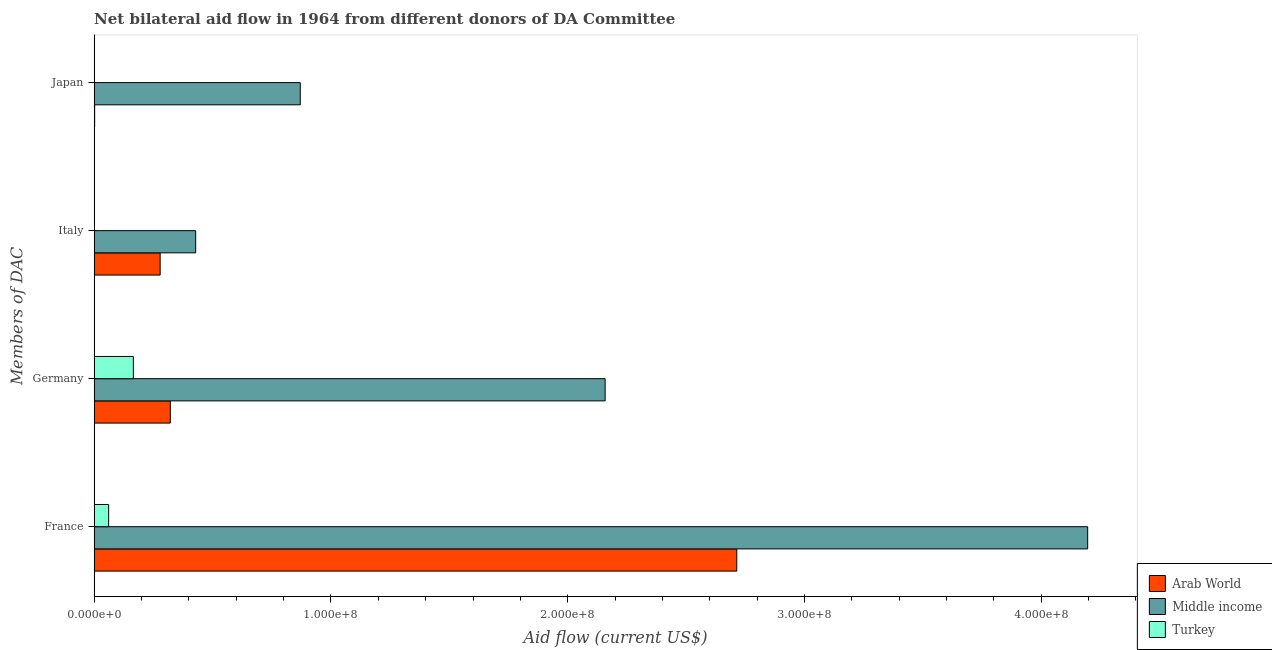How many different coloured bars are there?
Your answer should be very brief. 3. How many bars are there on the 1st tick from the bottom?
Offer a terse response. 3. What is the label of the 2nd group of bars from the top?
Your answer should be very brief. Italy. What is the amount of aid given by germany in Middle income?
Provide a short and direct response. 2.16e+08. Across all countries, what is the maximum amount of aid given by france?
Keep it short and to the point. 4.20e+08. Across all countries, what is the minimum amount of aid given by germany?
Provide a short and direct response. 1.65e+07. What is the total amount of aid given by italy in the graph?
Your answer should be very brief. 7.07e+07. What is the difference between the amount of aid given by germany in Turkey and that in Middle income?
Your answer should be compact. -1.99e+08. What is the difference between the amount of aid given by germany in Middle income and the amount of aid given by italy in Turkey?
Your answer should be very brief. 2.16e+08. What is the average amount of aid given by germany per country?
Give a very brief answer. 8.82e+07. What is the difference between the amount of aid given by japan and amount of aid given by france in Turkey?
Provide a succinct answer. -6.07e+06. In how many countries, is the amount of aid given by italy greater than 420000000 US$?
Offer a very short reply. 0. What is the ratio of the amount of aid given by germany in Arab World to that in Turkey?
Ensure brevity in your answer.  1.94. What is the difference between the highest and the second highest amount of aid given by germany?
Your answer should be compact. 1.84e+08. What is the difference between the highest and the lowest amount of aid given by italy?
Your answer should be compact. 4.29e+07. Is the sum of the amount of aid given by germany in Arab World and Middle income greater than the maximum amount of aid given by france across all countries?
Your response must be concise. No. How many bars are there?
Your answer should be compact. 11. Are the values on the major ticks of X-axis written in scientific E-notation?
Make the answer very short. Yes. Does the graph contain any zero values?
Your response must be concise. Yes. Does the graph contain grids?
Give a very brief answer. No. Where does the legend appear in the graph?
Your answer should be compact. Bottom right. How many legend labels are there?
Give a very brief answer. 3. How are the legend labels stacked?
Your answer should be very brief. Vertical. What is the title of the graph?
Your response must be concise. Net bilateral aid flow in 1964 from different donors of DA Committee. Does "Middle income" appear as one of the legend labels in the graph?
Keep it short and to the point. Yes. What is the label or title of the X-axis?
Offer a terse response. Aid flow (current US$). What is the label or title of the Y-axis?
Provide a succinct answer. Members of DAC. What is the Aid flow (current US$) in Arab World in France?
Offer a very short reply. 2.71e+08. What is the Aid flow (current US$) in Middle income in France?
Offer a terse response. 4.20e+08. What is the Aid flow (current US$) of Turkey in France?
Provide a succinct answer. 6.10e+06. What is the Aid flow (current US$) of Arab World in Germany?
Ensure brevity in your answer.  3.22e+07. What is the Aid flow (current US$) in Middle income in Germany?
Offer a terse response. 2.16e+08. What is the Aid flow (current US$) of Turkey in Germany?
Make the answer very short. 1.65e+07. What is the Aid flow (current US$) of Arab World in Italy?
Give a very brief answer. 2.79e+07. What is the Aid flow (current US$) in Middle income in Italy?
Your answer should be very brief. 4.29e+07. What is the Aid flow (current US$) in Turkey in Italy?
Your answer should be very brief. 0. What is the Aid flow (current US$) in Middle income in Japan?
Provide a short and direct response. 8.70e+07. What is the Aid flow (current US$) of Turkey in Japan?
Make the answer very short. 3.00e+04. Across all Members of DAC, what is the maximum Aid flow (current US$) in Arab World?
Keep it short and to the point. 2.71e+08. Across all Members of DAC, what is the maximum Aid flow (current US$) of Middle income?
Provide a succinct answer. 4.20e+08. Across all Members of DAC, what is the maximum Aid flow (current US$) in Turkey?
Offer a terse response. 1.65e+07. Across all Members of DAC, what is the minimum Aid flow (current US$) in Middle income?
Provide a succinct answer. 4.29e+07. Across all Members of DAC, what is the minimum Aid flow (current US$) in Turkey?
Provide a short and direct response. 0. What is the total Aid flow (current US$) in Arab World in the graph?
Your answer should be compact. 3.32e+08. What is the total Aid flow (current US$) of Middle income in the graph?
Ensure brevity in your answer.  7.65e+08. What is the total Aid flow (current US$) in Turkey in the graph?
Give a very brief answer. 2.27e+07. What is the difference between the Aid flow (current US$) in Arab World in France and that in Germany?
Make the answer very short. 2.39e+08. What is the difference between the Aid flow (current US$) in Middle income in France and that in Germany?
Your answer should be compact. 2.04e+08. What is the difference between the Aid flow (current US$) in Turkey in France and that in Germany?
Give a very brief answer. -1.04e+07. What is the difference between the Aid flow (current US$) of Arab World in France and that in Italy?
Offer a terse response. 2.44e+08. What is the difference between the Aid flow (current US$) in Middle income in France and that in Italy?
Your response must be concise. 3.77e+08. What is the difference between the Aid flow (current US$) of Arab World in France and that in Japan?
Offer a very short reply. 2.71e+08. What is the difference between the Aid flow (current US$) in Middle income in France and that in Japan?
Offer a terse response. 3.33e+08. What is the difference between the Aid flow (current US$) in Turkey in France and that in Japan?
Your answer should be very brief. 6.07e+06. What is the difference between the Aid flow (current US$) in Arab World in Germany and that in Italy?
Make the answer very short. 4.29e+06. What is the difference between the Aid flow (current US$) in Middle income in Germany and that in Italy?
Keep it short and to the point. 1.73e+08. What is the difference between the Aid flow (current US$) of Arab World in Germany and that in Japan?
Ensure brevity in your answer.  3.20e+07. What is the difference between the Aid flow (current US$) of Middle income in Germany and that in Japan?
Offer a terse response. 1.29e+08. What is the difference between the Aid flow (current US$) of Turkey in Germany and that in Japan?
Your response must be concise. 1.65e+07. What is the difference between the Aid flow (current US$) in Arab World in Italy and that in Japan?
Keep it short and to the point. 2.77e+07. What is the difference between the Aid flow (current US$) in Middle income in Italy and that in Japan?
Offer a terse response. -4.42e+07. What is the difference between the Aid flow (current US$) in Arab World in France and the Aid flow (current US$) in Middle income in Germany?
Offer a terse response. 5.56e+07. What is the difference between the Aid flow (current US$) in Arab World in France and the Aid flow (current US$) in Turkey in Germany?
Your answer should be compact. 2.55e+08. What is the difference between the Aid flow (current US$) of Middle income in France and the Aid flow (current US$) of Turkey in Germany?
Offer a terse response. 4.03e+08. What is the difference between the Aid flow (current US$) of Arab World in France and the Aid flow (current US$) of Middle income in Italy?
Offer a terse response. 2.29e+08. What is the difference between the Aid flow (current US$) in Arab World in France and the Aid flow (current US$) in Middle income in Japan?
Your response must be concise. 1.84e+08. What is the difference between the Aid flow (current US$) of Arab World in France and the Aid flow (current US$) of Turkey in Japan?
Ensure brevity in your answer.  2.71e+08. What is the difference between the Aid flow (current US$) in Middle income in France and the Aid flow (current US$) in Turkey in Japan?
Provide a succinct answer. 4.20e+08. What is the difference between the Aid flow (current US$) in Arab World in Germany and the Aid flow (current US$) in Middle income in Italy?
Offer a terse response. -1.07e+07. What is the difference between the Aid flow (current US$) in Arab World in Germany and the Aid flow (current US$) in Middle income in Japan?
Offer a terse response. -5.49e+07. What is the difference between the Aid flow (current US$) of Arab World in Germany and the Aid flow (current US$) of Turkey in Japan?
Your answer should be compact. 3.21e+07. What is the difference between the Aid flow (current US$) in Middle income in Germany and the Aid flow (current US$) in Turkey in Japan?
Your answer should be very brief. 2.16e+08. What is the difference between the Aid flow (current US$) in Arab World in Italy and the Aid flow (current US$) in Middle income in Japan?
Offer a very short reply. -5.92e+07. What is the difference between the Aid flow (current US$) of Arab World in Italy and the Aid flow (current US$) of Turkey in Japan?
Make the answer very short. 2.78e+07. What is the difference between the Aid flow (current US$) of Middle income in Italy and the Aid flow (current US$) of Turkey in Japan?
Your answer should be compact. 4.28e+07. What is the average Aid flow (current US$) of Arab World per Members of DAC?
Make the answer very short. 8.29e+07. What is the average Aid flow (current US$) of Middle income per Members of DAC?
Give a very brief answer. 1.91e+08. What is the average Aid flow (current US$) in Turkey per Members of DAC?
Make the answer very short. 5.66e+06. What is the difference between the Aid flow (current US$) of Arab World and Aid flow (current US$) of Middle income in France?
Offer a very short reply. -1.48e+08. What is the difference between the Aid flow (current US$) in Arab World and Aid flow (current US$) in Turkey in France?
Your answer should be very brief. 2.65e+08. What is the difference between the Aid flow (current US$) in Middle income and Aid flow (current US$) in Turkey in France?
Keep it short and to the point. 4.14e+08. What is the difference between the Aid flow (current US$) of Arab World and Aid flow (current US$) of Middle income in Germany?
Your answer should be very brief. -1.84e+08. What is the difference between the Aid flow (current US$) of Arab World and Aid flow (current US$) of Turkey in Germany?
Your answer should be very brief. 1.56e+07. What is the difference between the Aid flow (current US$) of Middle income and Aid flow (current US$) of Turkey in Germany?
Provide a succinct answer. 1.99e+08. What is the difference between the Aid flow (current US$) of Arab World and Aid flow (current US$) of Middle income in Italy?
Ensure brevity in your answer.  -1.50e+07. What is the difference between the Aid flow (current US$) in Arab World and Aid flow (current US$) in Middle income in Japan?
Your answer should be very brief. -8.68e+07. What is the difference between the Aid flow (current US$) of Middle income and Aid flow (current US$) of Turkey in Japan?
Keep it short and to the point. 8.70e+07. What is the ratio of the Aid flow (current US$) in Arab World in France to that in Germany?
Give a very brief answer. 8.44. What is the ratio of the Aid flow (current US$) of Middle income in France to that in Germany?
Provide a short and direct response. 1.94. What is the ratio of the Aid flow (current US$) of Turkey in France to that in Germany?
Offer a very short reply. 0.37. What is the ratio of the Aid flow (current US$) in Arab World in France to that in Italy?
Your answer should be compact. 9.74. What is the ratio of the Aid flow (current US$) of Middle income in France to that in Italy?
Provide a succinct answer. 9.79. What is the ratio of the Aid flow (current US$) of Arab World in France to that in Japan?
Keep it short and to the point. 1428.42. What is the ratio of the Aid flow (current US$) in Middle income in France to that in Japan?
Your answer should be very brief. 4.82. What is the ratio of the Aid flow (current US$) in Turkey in France to that in Japan?
Give a very brief answer. 203.33. What is the ratio of the Aid flow (current US$) of Arab World in Germany to that in Italy?
Offer a terse response. 1.15. What is the ratio of the Aid flow (current US$) in Middle income in Germany to that in Italy?
Ensure brevity in your answer.  5.04. What is the ratio of the Aid flow (current US$) of Arab World in Germany to that in Japan?
Offer a very short reply. 169.21. What is the ratio of the Aid flow (current US$) in Middle income in Germany to that in Japan?
Provide a succinct answer. 2.48. What is the ratio of the Aid flow (current US$) of Turkey in Germany to that in Japan?
Offer a terse response. 551. What is the ratio of the Aid flow (current US$) in Arab World in Italy to that in Japan?
Offer a terse response. 146.63. What is the ratio of the Aid flow (current US$) in Middle income in Italy to that in Japan?
Offer a terse response. 0.49. What is the difference between the highest and the second highest Aid flow (current US$) of Arab World?
Ensure brevity in your answer.  2.39e+08. What is the difference between the highest and the second highest Aid flow (current US$) in Middle income?
Give a very brief answer. 2.04e+08. What is the difference between the highest and the second highest Aid flow (current US$) in Turkey?
Your answer should be very brief. 1.04e+07. What is the difference between the highest and the lowest Aid flow (current US$) of Arab World?
Offer a very short reply. 2.71e+08. What is the difference between the highest and the lowest Aid flow (current US$) of Middle income?
Give a very brief answer. 3.77e+08. What is the difference between the highest and the lowest Aid flow (current US$) of Turkey?
Your response must be concise. 1.65e+07. 